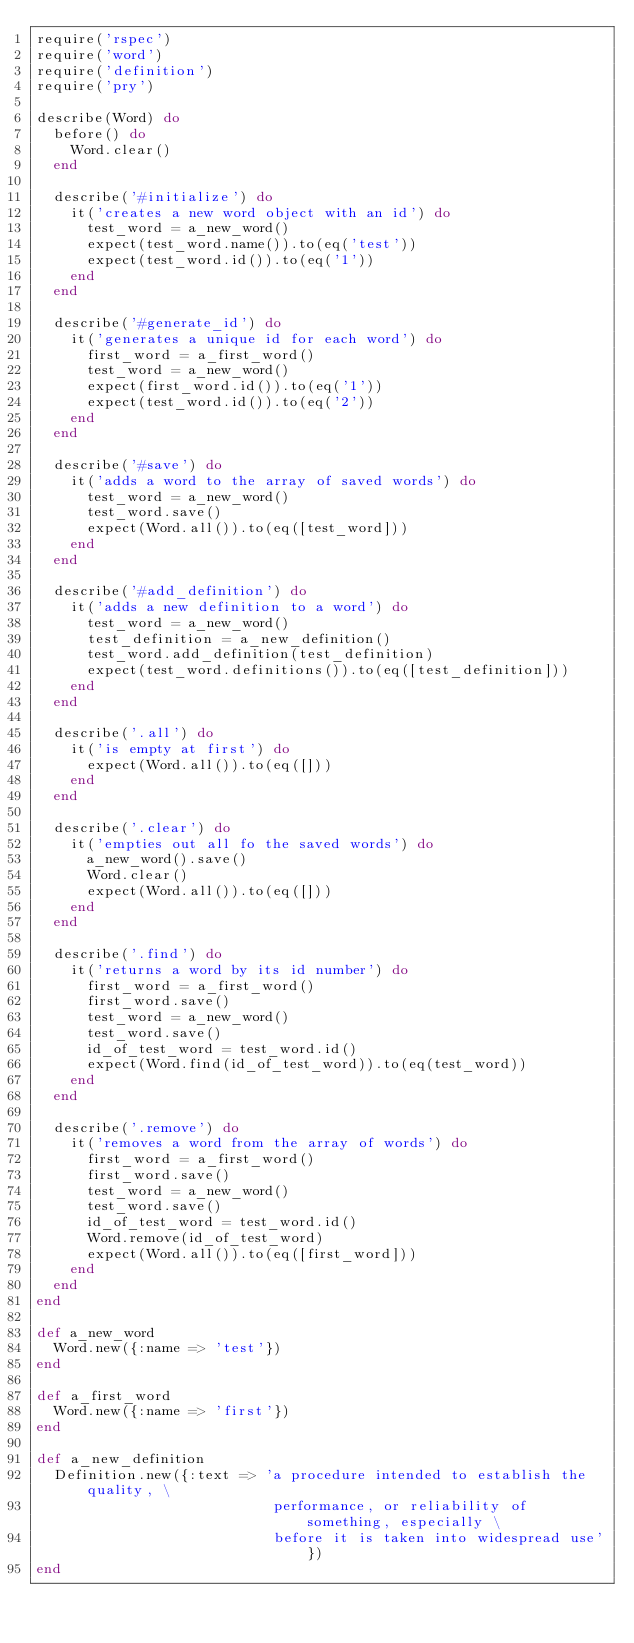Convert code to text. <code><loc_0><loc_0><loc_500><loc_500><_Ruby_>require('rspec')
require('word')
require('definition')
require('pry')

describe(Word) do
  before() do
    Word.clear()
  end

  describe('#initialize') do
    it('creates a new word object with an id') do
      test_word = a_new_word()
      expect(test_word.name()).to(eq('test'))
      expect(test_word.id()).to(eq('1'))
    end
  end

  describe('#generate_id') do
    it('generates a unique id for each word') do
      first_word = a_first_word()
      test_word = a_new_word()
      expect(first_word.id()).to(eq('1'))
      expect(test_word.id()).to(eq('2'))
    end
  end

  describe('#save') do
    it('adds a word to the array of saved words') do
      test_word = a_new_word()
      test_word.save()
      expect(Word.all()).to(eq([test_word]))
    end
  end

  describe('#add_definition') do
    it('adds a new definition to a word') do
      test_word = a_new_word()
      test_definition = a_new_definition()
      test_word.add_definition(test_definition)
      expect(test_word.definitions()).to(eq([test_definition]))
    end
  end

  describe('.all') do
    it('is empty at first') do
      expect(Word.all()).to(eq([]))
    end
  end

  describe('.clear') do
    it('empties out all fo the saved words') do
      a_new_word().save()
      Word.clear()
      expect(Word.all()).to(eq([]))
    end
  end

  describe('.find') do
    it('returns a word by its id number') do
      first_word = a_first_word()
      first_word.save()
      test_word = a_new_word()
      test_word.save()
      id_of_test_word = test_word.id()
      expect(Word.find(id_of_test_word)).to(eq(test_word))
    end
  end

  describe('.remove') do
    it('removes a word from the array of words') do
      first_word = a_first_word()
      first_word.save()
      test_word = a_new_word()
      test_word.save()
      id_of_test_word = test_word.id()
      Word.remove(id_of_test_word)
      expect(Word.all()).to(eq([first_word]))
    end
  end
end

def a_new_word
  Word.new({:name => 'test'})
end

def a_first_word
  Word.new({:name => 'first'})
end

def a_new_definition
  Definition.new({:text => 'a procedure intended to establish the quality, \
                            performance, or reliability of something, especially \
                            before it is taken into widespread use'})
end
</code> 